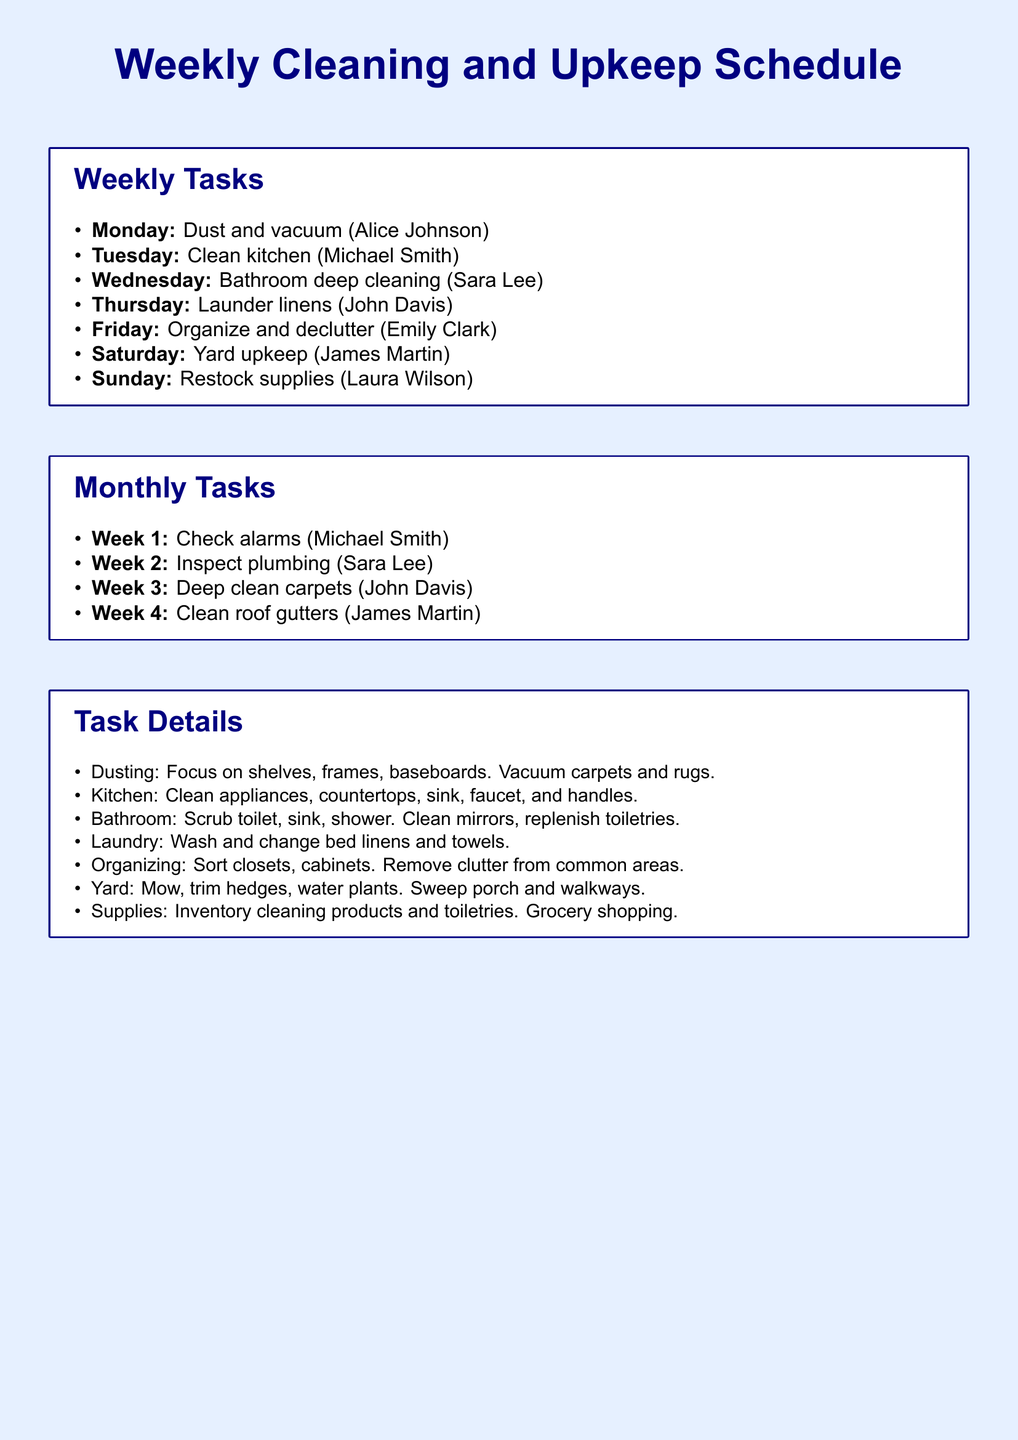what task is assigned to Tuesday? The document lists tasks for each day of the week, and Tuesday is assigned to clean the kitchen.
Answer: Clean kitchen who is responsible for laundry on Thursday? The document specifies that John Davis is assigned to launder linens on Thursday.
Answer: John Davis how many total weekly tasks are listed? The document outlines seven tasks for the week, one for each day from Monday to Sunday.
Answer: 7 which day is designated for restocking supplies? The schedule clearly states that Sunday is the day for restocking supplies, assigned to Laura Wilson.
Answer: Sunday what type of cleaning is scheduled for Wednesday? The task assigned on Wednesday is bathroom deep cleaning, which is explicitly mentioned in the document.
Answer: Bathroom deep cleaning who is in charge of inspecting plumbing in the monthly tasks? The document indicates that Sara Lee is responsible for inspecting plumbing during Week 2 of the monthly tasks.
Answer: Sara Lee which task involves mowing the lawn? The weekly task for Saturday is designated as yard upkeep, which includes mowing the lawn according to the document.
Answer: Yard upkeep how many monthly tasks are described in the document? The document details four monthly tasks, each corresponding to a specific week.
Answer: 4 what is the main focus of the dusting task? According to the task details, the dusting task focuses on shelves, frames, and baseboards.
Answer: Shelves, frames, baseboards 